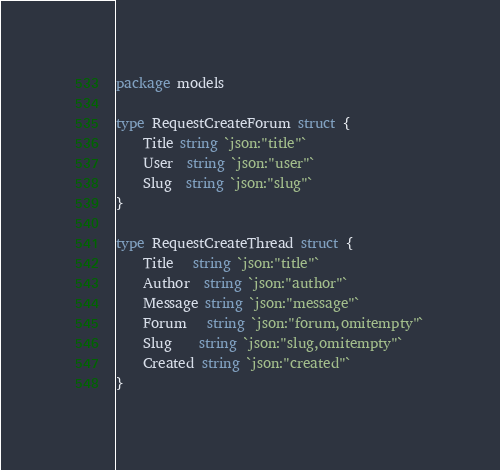Convert code to text. <code><loc_0><loc_0><loc_500><loc_500><_Go_>package models

type RequestCreateForum struct {
	Title string `json:"title"`
	User  string `json:"user"`
	Slug  string `json:"slug"`
}

type RequestCreateThread struct {
	Title   string `json:"title"`
	Author  string `json:"author"`
	Message string `json:"message"`
	Forum   string `json:"forum,omitempty"`
	Slug    string `json:"slug,omitempty"`
	Created string `json:"created"`
}
</code> 